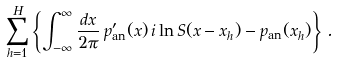<formula> <loc_0><loc_0><loc_500><loc_500>\sum _ { h = 1 } ^ { H } \left \{ \int _ { - \infty } ^ { \infty } \frac { d x } { 2 \pi } \, p _ { \text {an} } ^ { \prime } ( x ) \, i \ln S ( x - x _ { h } ) - p _ { \text {an} } ( x _ { h } ) \right \} \, .</formula> 